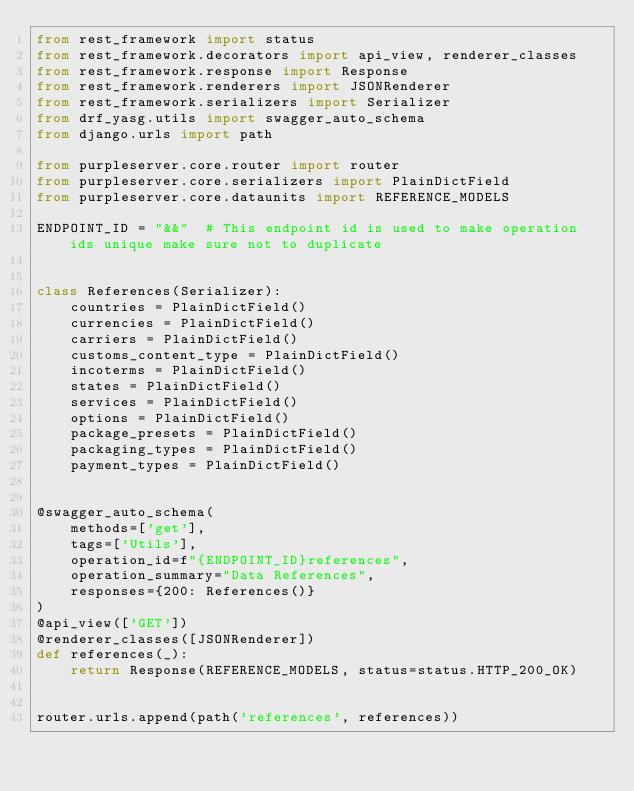<code> <loc_0><loc_0><loc_500><loc_500><_Python_>from rest_framework import status
from rest_framework.decorators import api_view, renderer_classes
from rest_framework.response import Response
from rest_framework.renderers import JSONRenderer
from rest_framework.serializers import Serializer
from drf_yasg.utils import swagger_auto_schema
from django.urls import path

from purpleserver.core.router import router
from purpleserver.core.serializers import PlainDictField
from purpleserver.core.dataunits import REFERENCE_MODELS

ENDPOINT_ID = "&&"  # This endpoint id is used to make operation ids unique make sure not to duplicate


class References(Serializer):
    countries = PlainDictField()
    currencies = PlainDictField()
    carriers = PlainDictField()
    customs_content_type = PlainDictField()
    incoterms = PlainDictField()
    states = PlainDictField()
    services = PlainDictField()
    options = PlainDictField()
    package_presets = PlainDictField()
    packaging_types = PlainDictField()
    payment_types = PlainDictField()


@swagger_auto_schema(
    methods=['get'],
    tags=['Utils'],
    operation_id=f"{ENDPOINT_ID}references",
    operation_summary="Data References",
    responses={200: References()}
)
@api_view(['GET'])
@renderer_classes([JSONRenderer])
def references(_):
    return Response(REFERENCE_MODELS, status=status.HTTP_200_OK)


router.urls.append(path('references', references))
</code> 